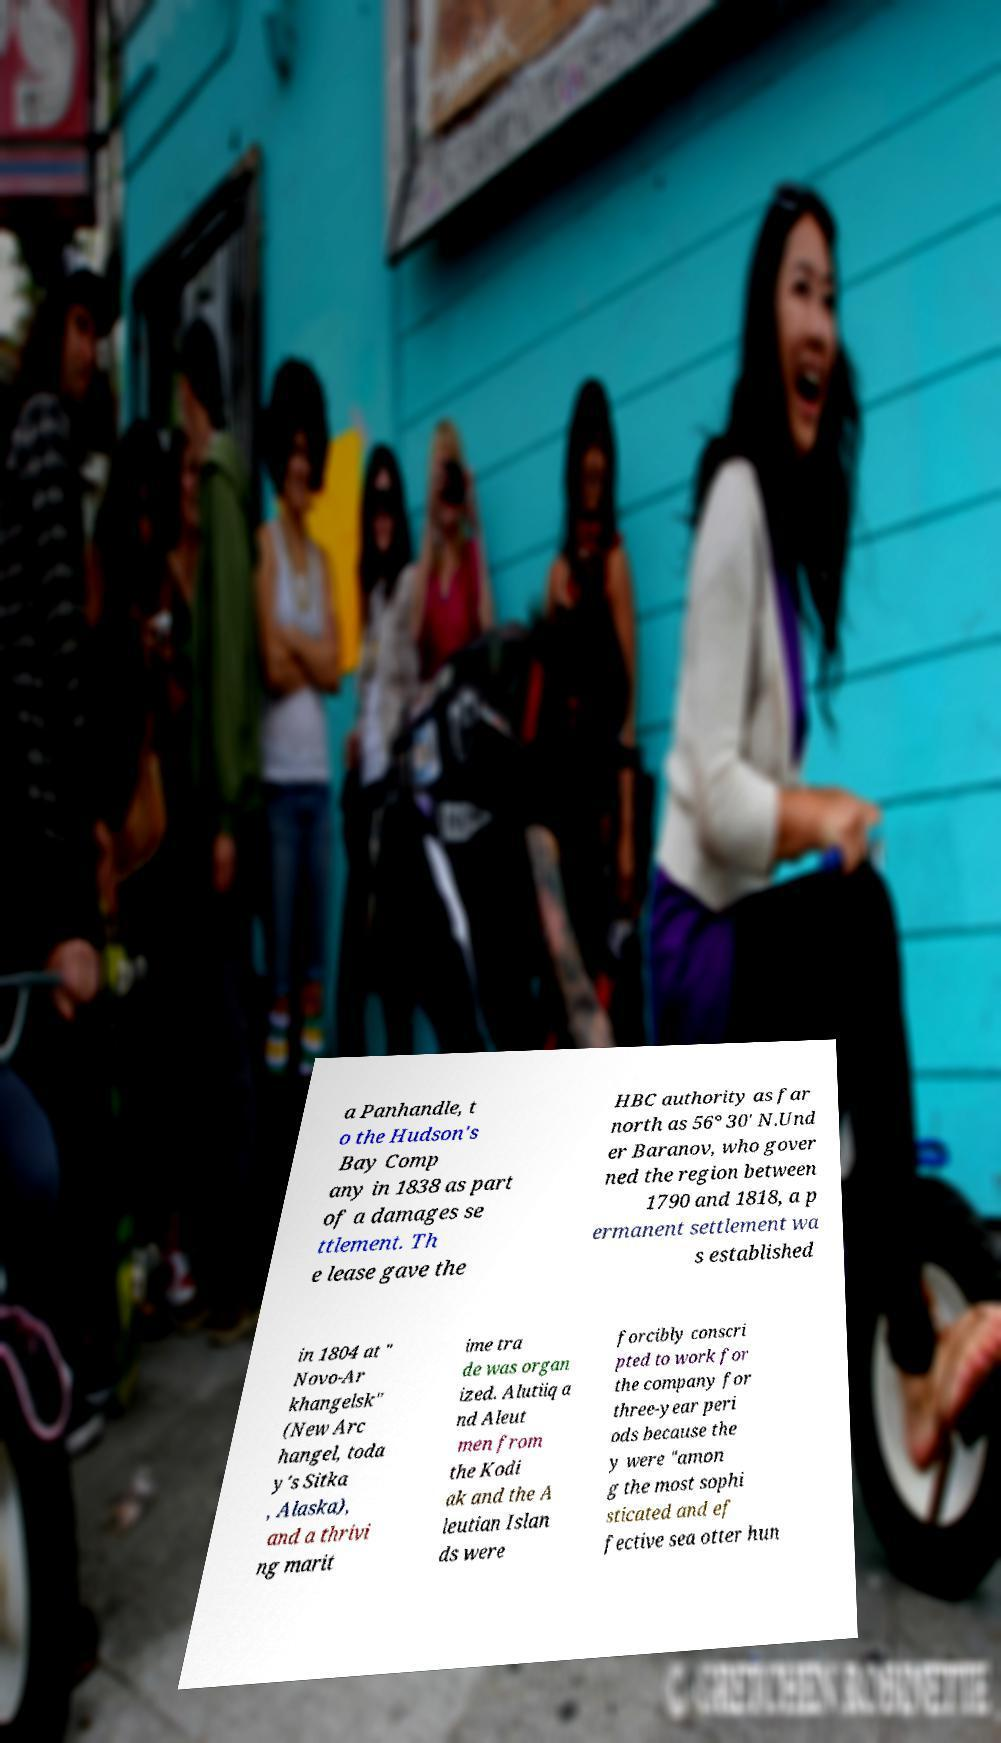Can you accurately transcribe the text from the provided image for me? a Panhandle, t o the Hudson's Bay Comp any in 1838 as part of a damages se ttlement. Th e lease gave the HBC authority as far north as 56° 30' N.Und er Baranov, who gover ned the region between 1790 and 1818, a p ermanent settlement wa s established in 1804 at " Novo-Ar khangelsk" (New Arc hangel, toda y's Sitka , Alaska), and a thrivi ng marit ime tra de was organ ized. Alutiiq a nd Aleut men from the Kodi ak and the A leutian Islan ds were forcibly conscri pted to work for the company for three-year peri ods because the y were "amon g the most sophi sticated and ef fective sea otter hun 